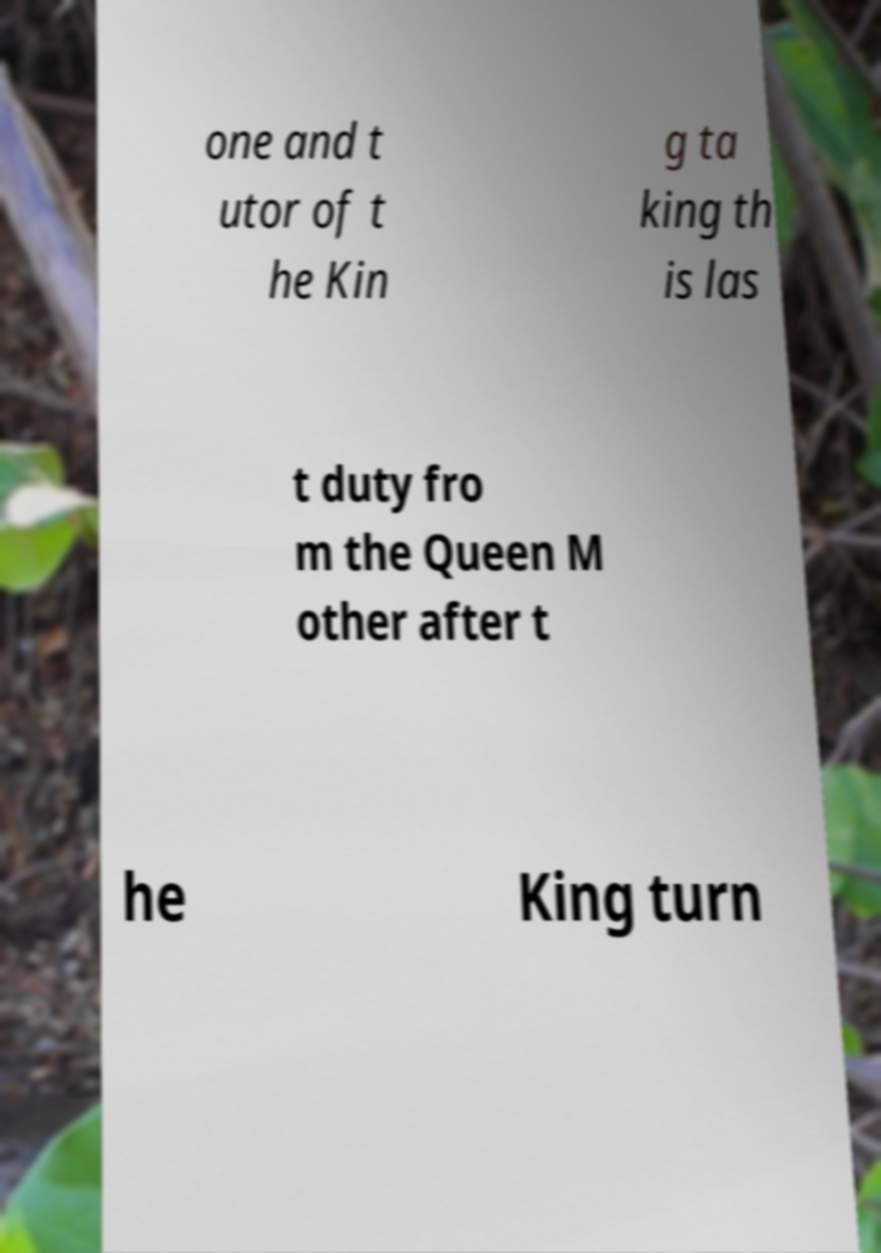Could you assist in decoding the text presented in this image and type it out clearly? one and t utor of t he Kin g ta king th is las t duty fro m the Queen M other after t he King turn 